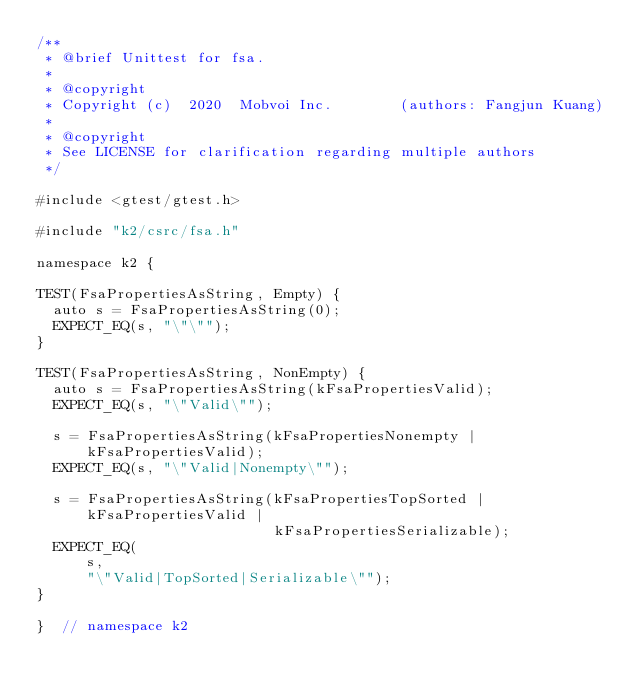<code> <loc_0><loc_0><loc_500><loc_500><_Cuda_>/**
 * @brief Unittest for fsa.
 *
 * @copyright
 * Copyright (c)  2020  Mobvoi Inc.        (authors: Fangjun Kuang)
 *
 * @copyright
 * See LICENSE for clarification regarding multiple authors
 */

#include <gtest/gtest.h>

#include "k2/csrc/fsa.h"

namespace k2 {

TEST(FsaPropertiesAsString, Empty) {
  auto s = FsaPropertiesAsString(0);
  EXPECT_EQ(s, "\"\"");
}

TEST(FsaPropertiesAsString, NonEmpty) {
  auto s = FsaPropertiesAsString(kFsaPropertiesValid);
  EXPECT_EQ(s, "\"Valid\"");

  s = FsaPropertiesAsString(kFsaPropertiesNonempty | kFsaPropertiesValid);
  EXPECT_EQ(s, "\"Valid|Nonempty\"");

  s = FsaPropertiesAsString(kFsaPropertiesTopSorted | kFsaPropertiesValid |
                            kFsaPropertiesSerializable);
  EXPECT_EQ(
      s,
      "\"Valid|TopSorted|Serializable\"");
}

}  // namespace k2
</code> 